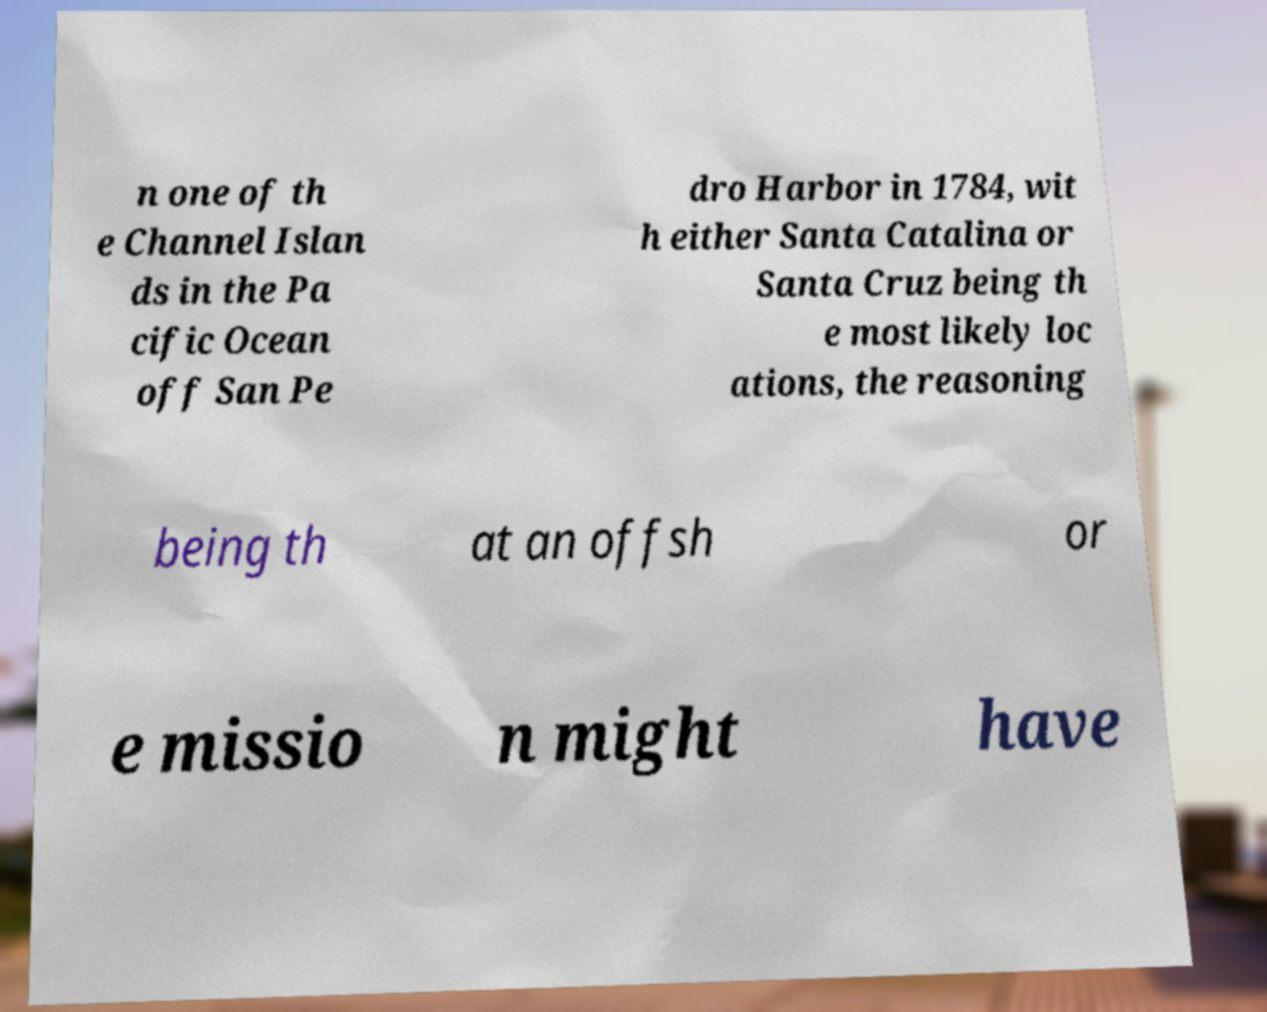Please identify and transcribe the text found in this image. n one of th e Channel Islan ds in the Pa cific Ocean off San Pe dro Harbor in 1784, wit h either Santa Catalina or Santa Cruz being th e most likely loc ations, the reasoning being th at an offsh or e missio n might have 